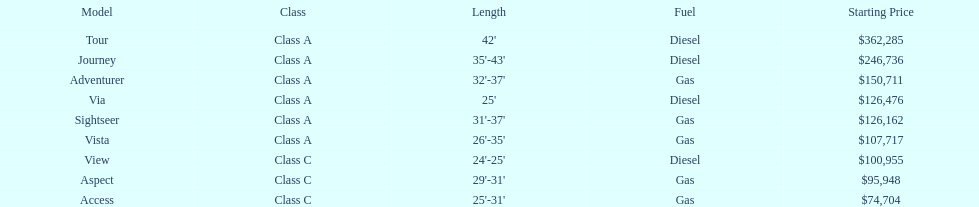Parse the full table. {'header': ['Model', 'Class', 'Length', 'Fuel', 'Starting Price'], 'rows': [['Tour', 'Class A', "42'", 'Diesel', '$362,285'], ['Journey', 'Class A', "35'-43'", 'Diesel', '$246,736'], ['Adventurer', 'Class A', "32'-37'", 'Gas', '$150,711'], ['Via', 'Class A', "25'", 'Diesel', '$126,476'], ['Sightseer', 'Class A', "31'-37'", 'Gas', '$126,162'], ['Vista', 'Class A', "26'-35'", 'Gas', '$107,717'], ['View', 'Class C', "24'-25'", 'Diesel', '$100,955'], ['Aspect', 'Class C', "29'-31'", 'Gas', '$95,948'], ['Access', 'Class C', "25'-31'", 'Gas', '$74,704']]} Can the vista be regarded as surpassing the aspect in value? Yes. 